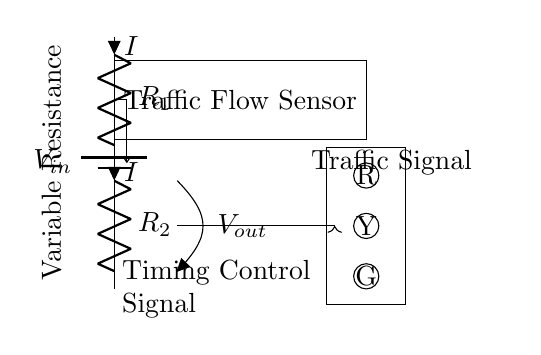What is the main function of the resistors in this circuit? The resistors R1 and R2 form a voltage divider that determines the output voltage based on the input voltage and the resistance values.
Answer: Voltage divider What does the output voltage represent in this circuit? The output voltage is proportional to the traffic flow detected by the sensor, which influences the timing control signal for the traffic signal.
Answer: Timing control signal How many resistors are present in the circuit? There are two resistors, R1 and R2, connected in series.
Answer: Two What happens to the output voltage if the resistance of R1 is increased? Increasing R1 will increase the output voltage, as a larger resistance would result in a greater proportion of the input voltage being dropped across R1.
Answer: Increases Which component is responsible for measuring traffic flow in this circuit? The Traffic Flow Sensor measures the vehicles passing, which adjusts the timing of the traffic signal based on the output voltage.
Answer: Traffic Flow Sensor What type of circuit configuration is used to control the traffic signal timing? A voltage divider configuration is used to regulate the output voltage for timing control based on input voltage and resistance ratios.
Answer: Voltage divider What effect would a decrease in R2 have on the circuit's operation? Decreasing R2 would lower the overall resistance in the divider, resulting in a higher output voltage, which could shorten the timing interval of the traffic signal.
Answer: Shortens timing interval 